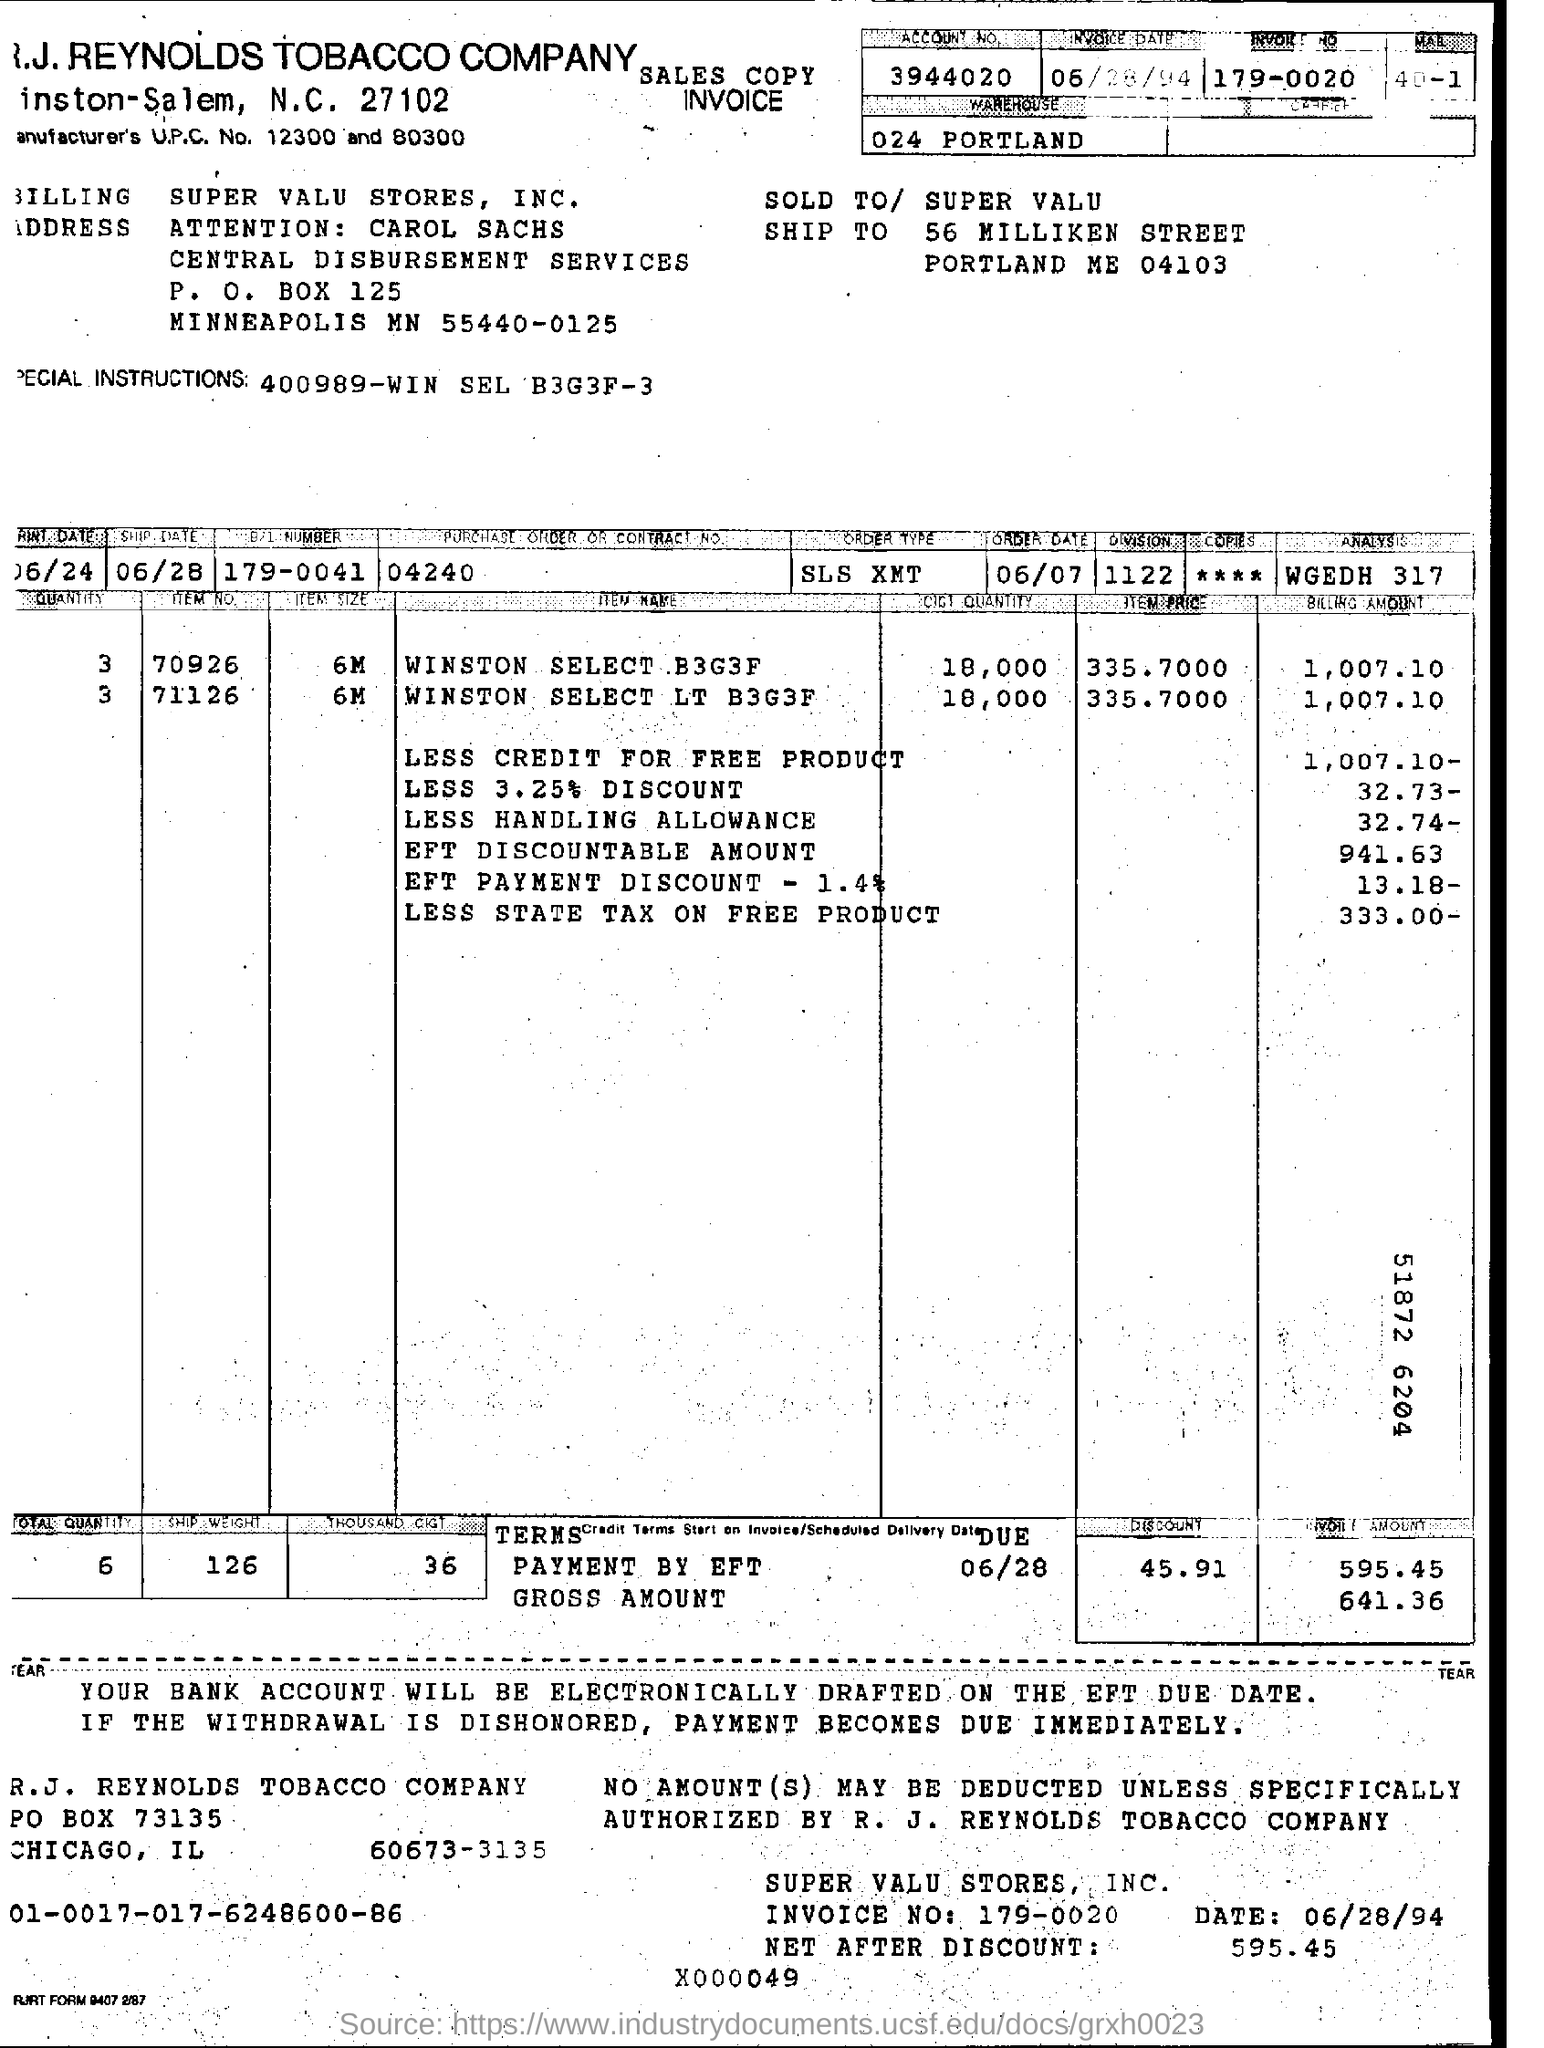What are the special instructions?
Ensure brevity in your answer.  400989-WIN SEL B3G3F-3. How much of billing amount for the less 3.25% discount ?
Ensure brevity in your answer.  32.73-. What is the account number ?
Make the answer very short. 3944020. What is the price of item for the winston select lt b3g3f?
Ensure brevity in your answer.  335.7000. 